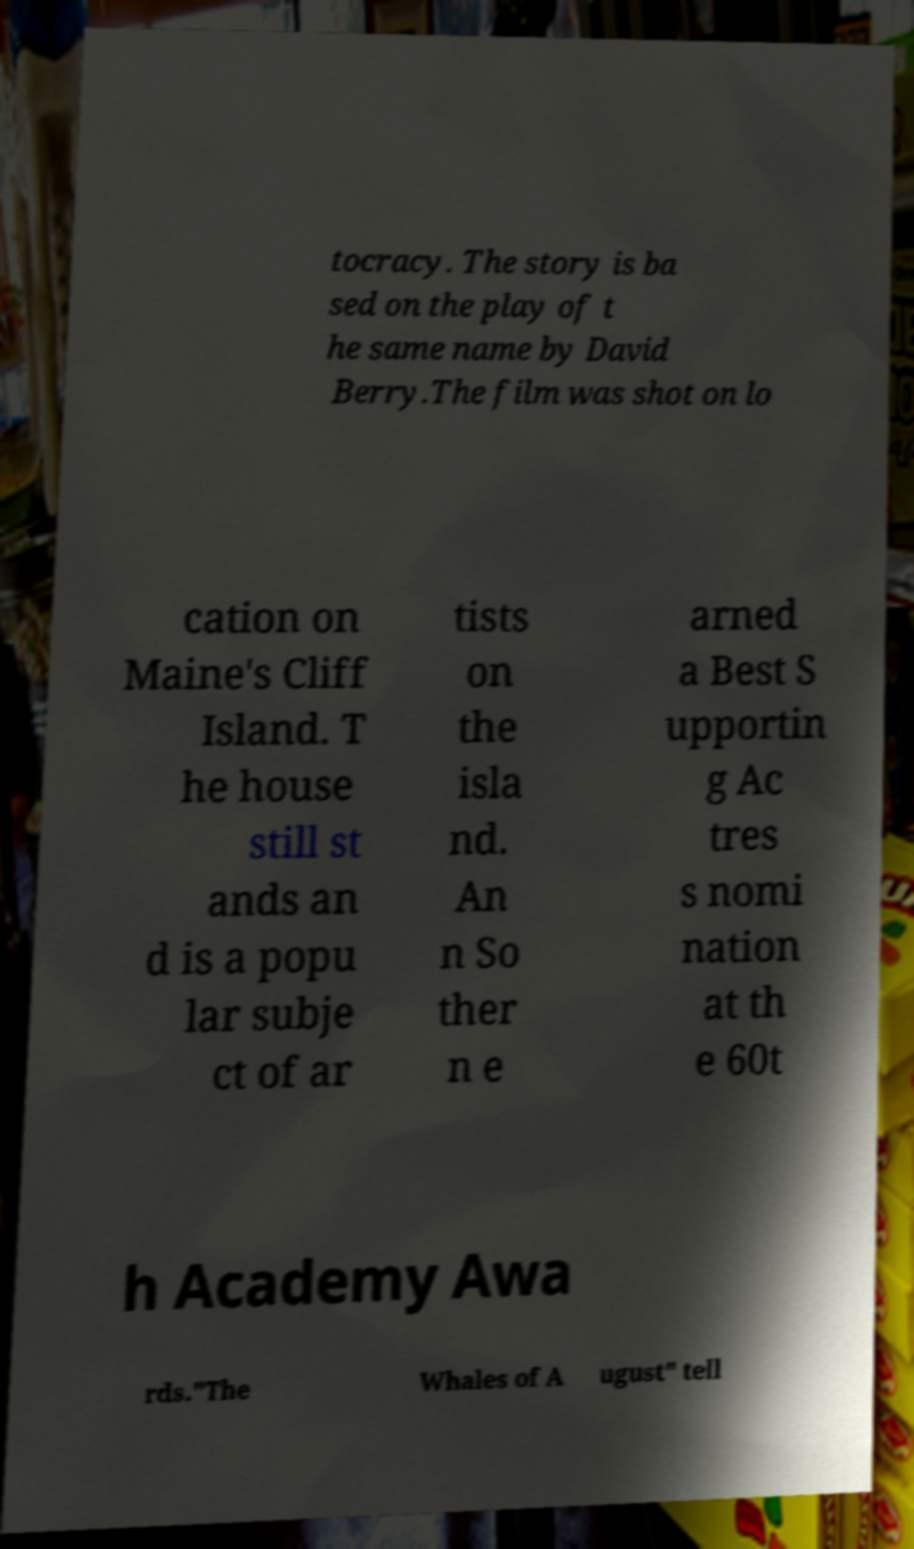There's text embedded in this image that I need extracted. Can you transcribe it verbatim? tocracy. The story is ba sed on the play of t he same name by David Berry.The film was shot on lo cation on Maine's Cliff Island. T he house still st ands an d is a popu lar subje ct of ar tists on the isla nd. An n So ther n e arned a Best S upportin g Ac tres s nomi nation at th e 60t h Academy Awa rds."The Whales of A ugust" tell 